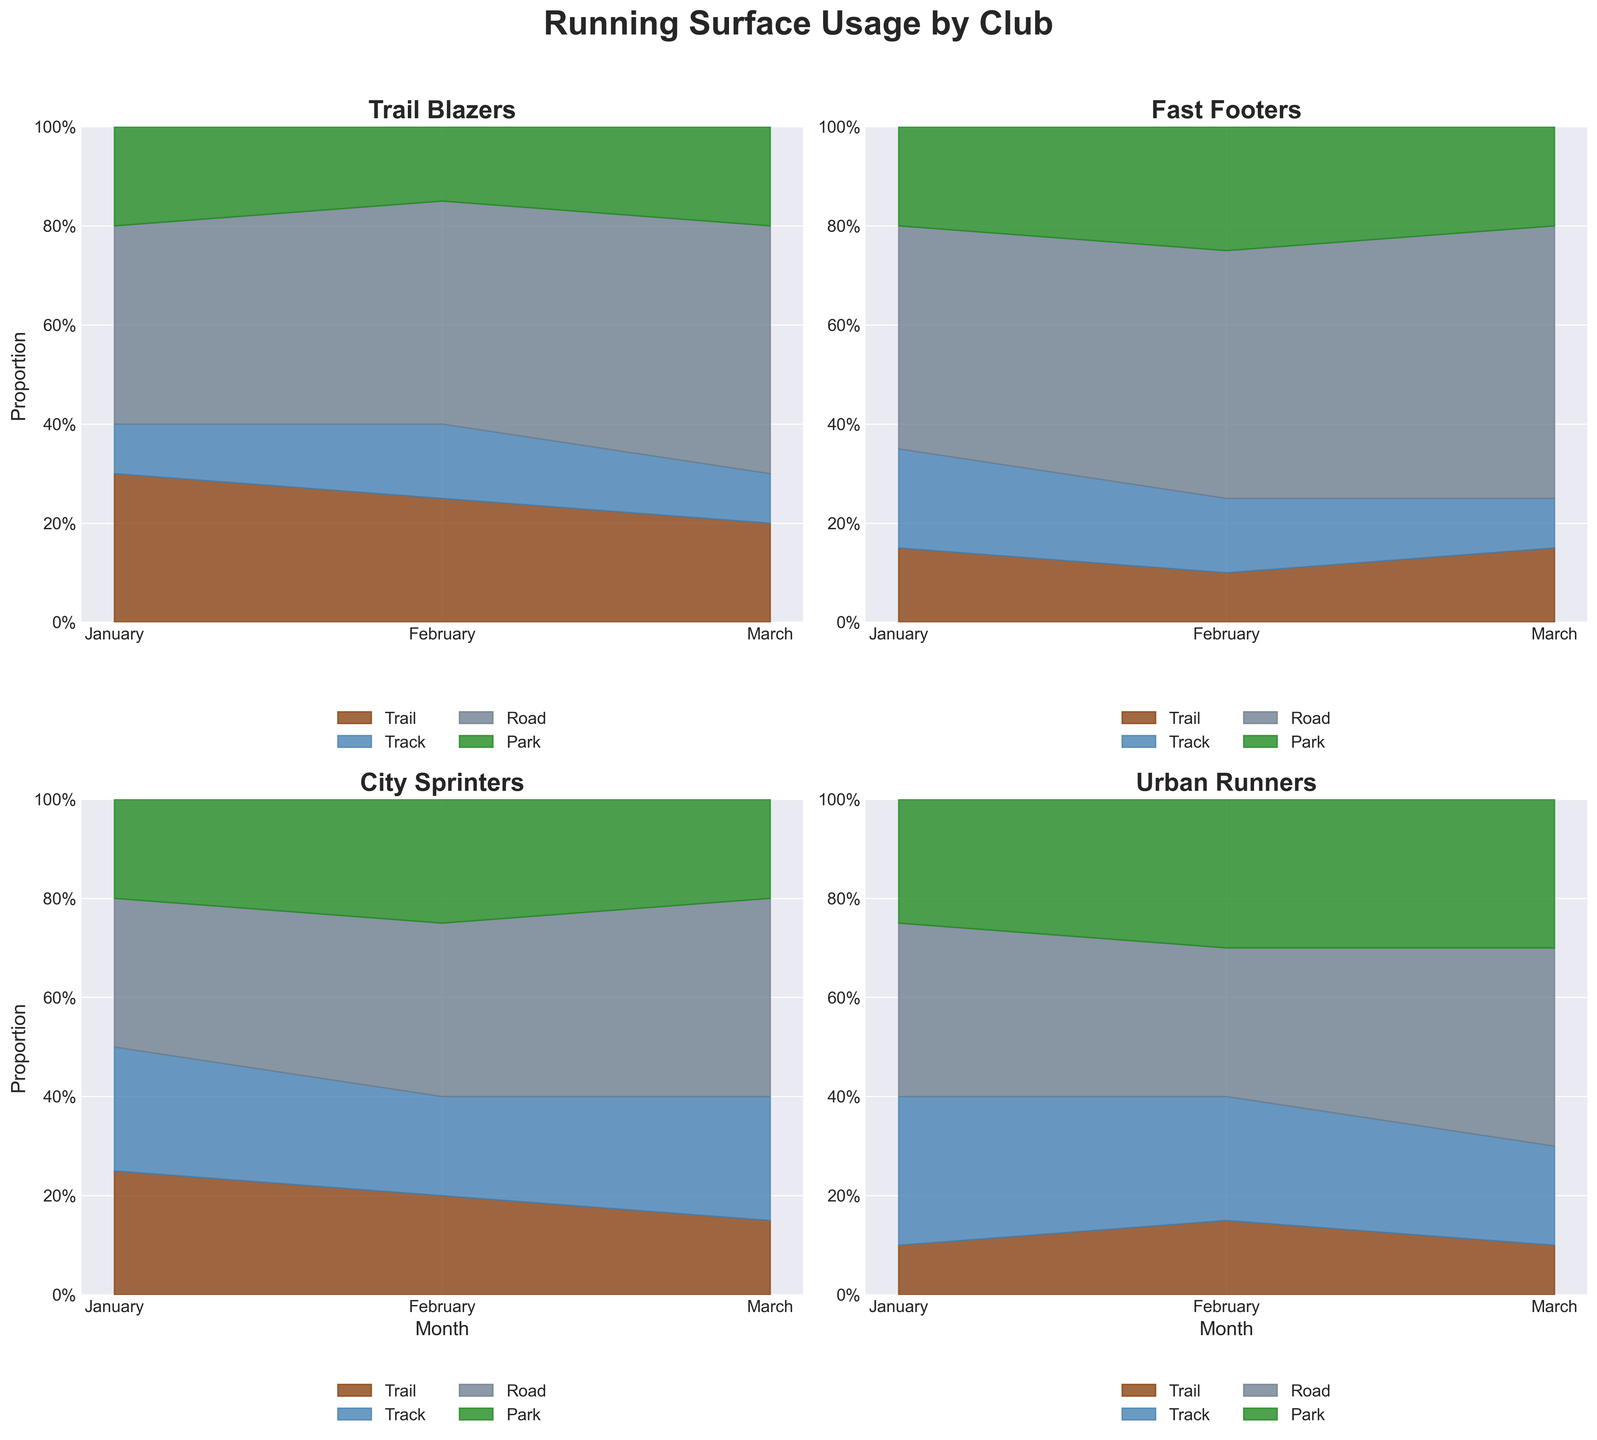Which club shows the highest proportion of 'Track' surface usage in January? Look at the segments representing 'Track' (typically in blue). Identify which club has the tallest 'Track' segment in January. In this case, Urban Runners have the highest segment for 'Track' with 30%.
Answer: Urban Runners For Trail Blazers, how does the proportion of 'Road' surface change from January to March? Inspect the 'Road' segments for the months January, February, and March. Note the percentages: 40% in January, 45% in February, and 50% in March. The 'Road' usage increases by 5% from January to February, and by another 5% from February to March.
Answer: Increases Which club had the most consistent use of 'Park' surfaces across the three months? Determine the segments representing 'Park' surfaces for all three months for each club. Compare the variations: Trail Blazers (20%-15%-20%), Fast Footers (20%-25%-20%), City Sprinters (20%-25%-20%), Urban Runners (25%-30%-30%). Urban Runners have the smallest change in 'Park' usage.
Answer: Urban Runners In March, which club has the smallest proportion of 'Track' surface usage? Identify the segments representing 'Track' surfaces for March. Compare the values and see that Trail Blazers and Fast Footers both have the smallest 'Track' surface usage at 10%.
Answer: Trail Blazers and Fast Footers For City Sprinters, what is the total proportion of 'Trail' and 'Track' surfaces combined in February? Sum the 'Trail' and 'Track' surface proportions for City Sprinters in February. Trail is 20% and Track is 20%, so the combined proportion is 20% + 20% = 40%.
Answer: 40% Which type of surface usage increased the most for Fast Footers from January to February? Compare the January and February segments for each surface type ('Trail', 'Track', 'Road', 'Park'). Calculate the changes: 'Trail' (-5%), 'Track' (-5%), 'Road' (+5%), and 'Park' (+5%). 'Road' and 'Park' both increased equally, by 5%.
Answer: Road and Park What is the maximum proportion of 'Park' surface usage across all clubs and months? Examine all 'Park' segments for each club over three months and find the maximum value. The highest value of 30% appears for Urban Runners in February and March.
Answer: 30% How did the 'Trail' surface usage of City Sprinters change from January to March? Observe the 'Trail' segments for City Sprinters over the three months. The proportions are 25% in January, 20% in February, and 15% in March. The 'Trail' usage decreases by 5% from January to February and again by 5% from February to March.
Answer: Decreases In which month do Trail Blazers have the highest usage of 'Road' surfaces? Look at the 'Road' segments for Trail Blazers across the three months. Identify that the highest usage is in March with 50%.
Answer: March 